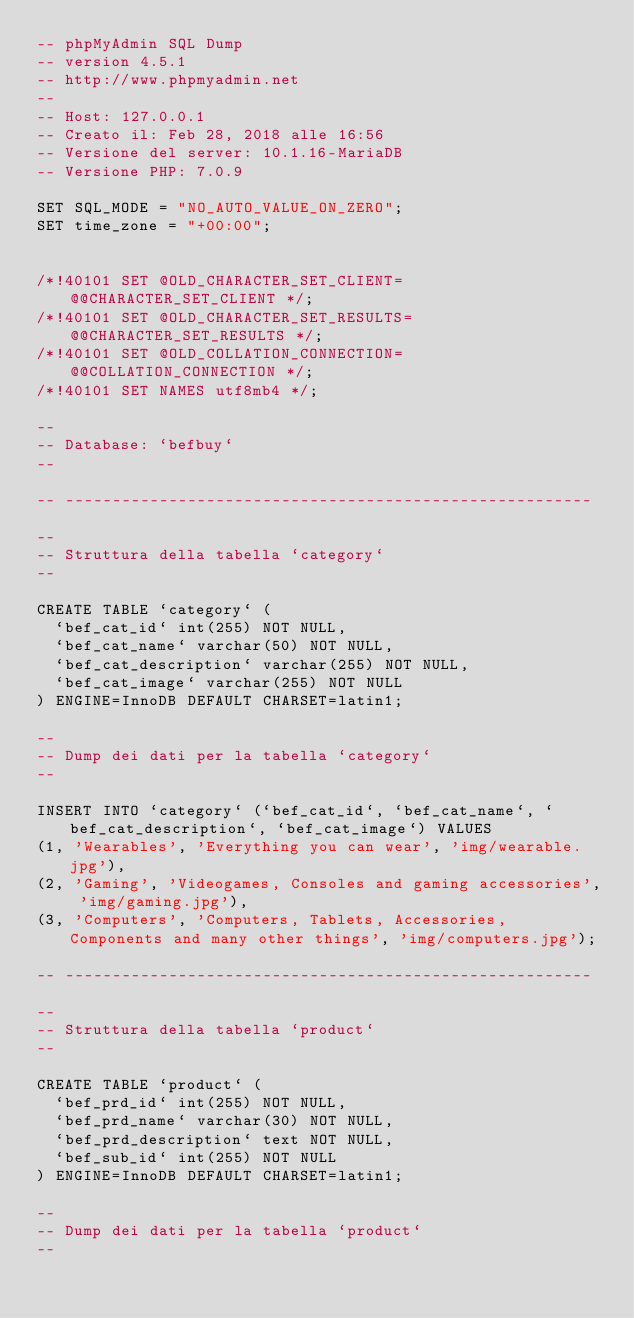Convert code to text. <code><loc_0><loc_0><loc_500><loc_500><_SQL_>-- phpMyAdmin SQL Dump
-- version 4.5.1
-- http://www.phpmyadmin.net
--
-- Host: 127.0.0.1
-- Creato il: Feb 28, 2018 alle 16:56
-- Versione del server: 10.1.16-MariaDB
-- Versione PHP: 7.0.9

SET SQL_MODE = "NO_AUTO_VALUE_ON_ZERO";
SET time_zone = "+00:00";


/*!40101 SET @OLD_CHARACTER_SET_CLIENT=@@CHARACTER_SET_CLIENT */;
/*!40101 SET @OLD_CHARACTER_SET_RESULTS=@@CHARACTER_SET_RESULTS */;
/*!40101 SET @OLD_COLLATION_CONNECTION=@@COLLATION_CONNECTION */;
/*!40101 SET NAMES utf8mb4 */;

--
-- Database: `befbuy`
--

-- --------------------------------------------------------

--
-- Struttura della tabella `category`
--

CREATE TABLE `category` (
  `bef_cat_id` int(255) NOT NULL,
  `bef_cat_name` varchar(50) NOT NULL,
  `bef_cat_description` varchar(255) NOT NULL,
  `bef_cat_image` varchar(255) NOT NULL
) ENGINE=InnoDB DEFAULT CHARSET=latin1;

--
-- Dump dei dati per la tabella `category`
--

INSERT INTO `category` (`bef_cat_id`, `bef_cat_name`, `bef_cat_description`, `bef_cat_image`) VALUES
(1, 'Wearables', 'Everything you can wear', 'img/wearable.jpg'),
(2, 'Gaming', 'Videogames, Consoles and gaming accessories', 'img/gaming.jpg'),
(3, 'Computers', 'Computers, Tablets, Accessories, Components and many other things', 'img/computers.jpg');

-- --------------------------------------------------------

--
-- Struttura della tabella `product`
--

CREATE TABLE `product` (
  `bef_prd_id` int(255) NOT NULL,
  `bef_prd_name` varchar(30) NOT NULL,
  `bef_prd_description` text NOT NULL,
  `bef_sub_id` int(255) NOT NULL
) ENGINE=InnoDB DEFAULT CHARSET=latin1;

--
-- Dump dei dati per la tabella `product`
--
</code> 